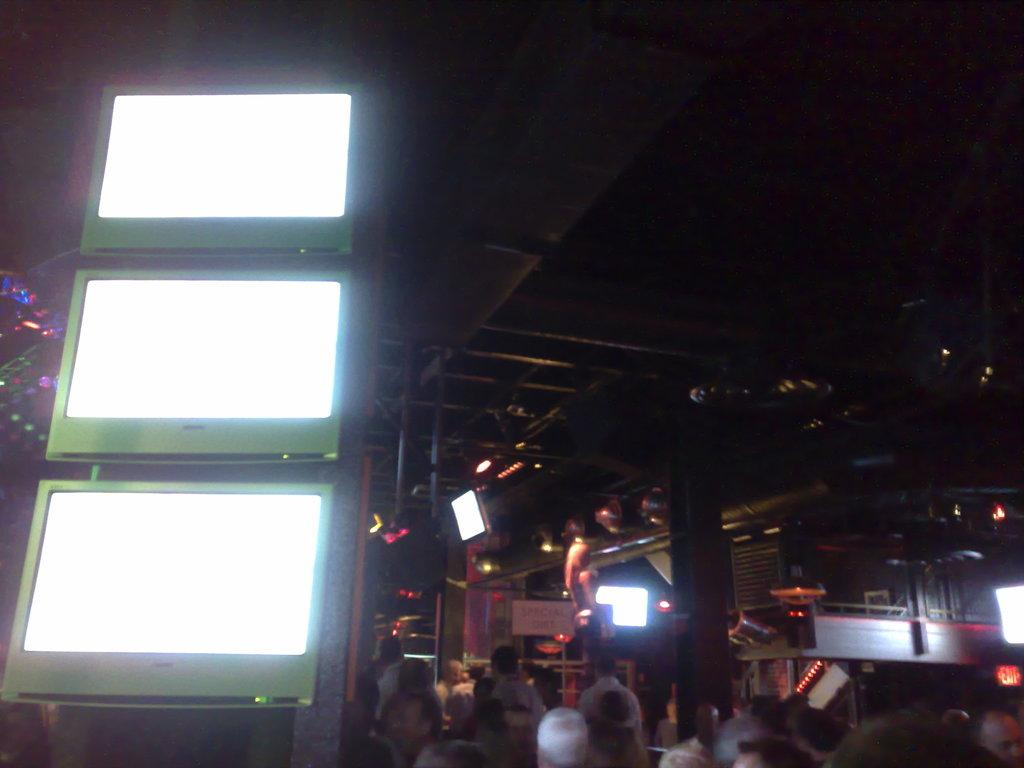What is present in the image? There are people, lights, screens, and iron poles in the image. Can you describe the appearance of the image? The image has a dark appearance. How many dimes are scattered on the floor in the image? There are no dimes present in the image. What type of toys can be seen being played with in the image? There are no toys present in the image. Is there a bone visible in the image? There is no bone visible in the image. 